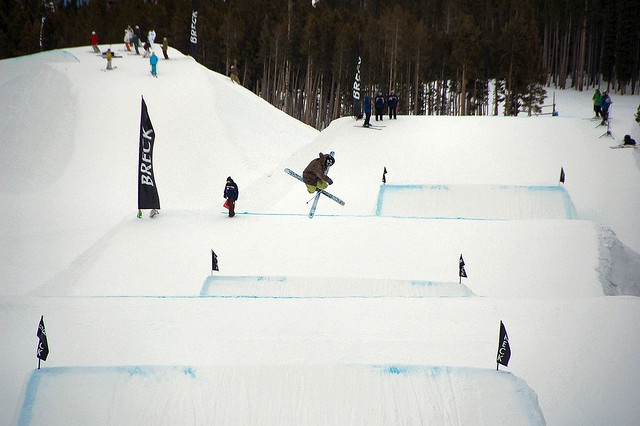Describe the objects in this image and their specific colors. I can see people in black, lightgray, darkgray, and gray tones, people in black, darkgreen, and gray tones, people in black, maroon, navy, and white tones, skis in black, darkgray, gray, and lightblue tones, and people in black, gray, darkgray, and darkgreen tones in this image. 